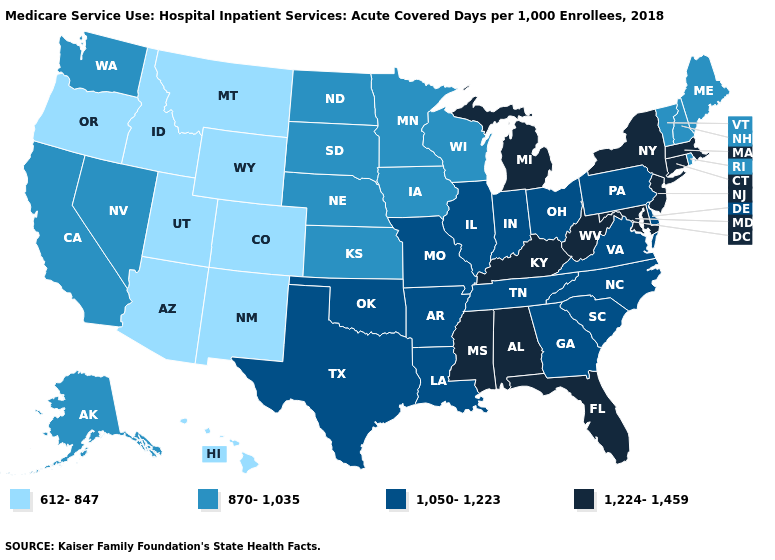Is the legend a continuous bar?
Concise answer only. No. Name the states that have a value in the range 612-847?
Short answer required. Arizona, Colorado, Hawaii, Idaho, Montana, New Mexico, Oregon, Utah, Wyoming. What is the value of Massachusetts?
Write a very short answer. 1,224-1,459. What is the lowest value in the USA?
Write a very short answer. 612-847. What is the lowest value in states that border Arkansas?
Be succinct. 1,050-1,223. Name the states that have a value in the range 1,050-1,223?
Concise answer only. Arkansas, Delaware, Georgia, Illinois, Indiana, Louisiana, Missouri, North Carolina, Ohio, Oklahoma, Pennsylvania, South Carolina, Tennessee, Texas, Virginia. What is the highest value in states that border California?
Be succinct. 870-1,035. Among the states that border Massachusetts , does Connecticut have the highest value?
Concise answer only. Yes. What is the lowest value in the South?
Write a very short answer. 1,050-1,223. Among the states that border Pennsylvania , does West Virginia have the lowest value?
Concise answer only. No. What is the highest value in the USA?
Be succinct. 1,224-1,459. How many symbols are there in the legend?
Keep it brief. 4. Which states have the lowest value in the Northeast?
Quick response, please. Maine, New Hampshire, Rhode Island, Vermont. Does Massachusetts have a higher value than Virginia?
Give a very brief answer. Yes. Name the states that have a value in the range 1,050-1,223?
Give a very brief answer. Arkansas, Delaware, Georgia, Illinois, Indiana, Louisiana, Missouri, North Carolina, Ohio, Oklahoma, Pennsylvania, South Carolina, Tennessee, Texas, Virginia. 